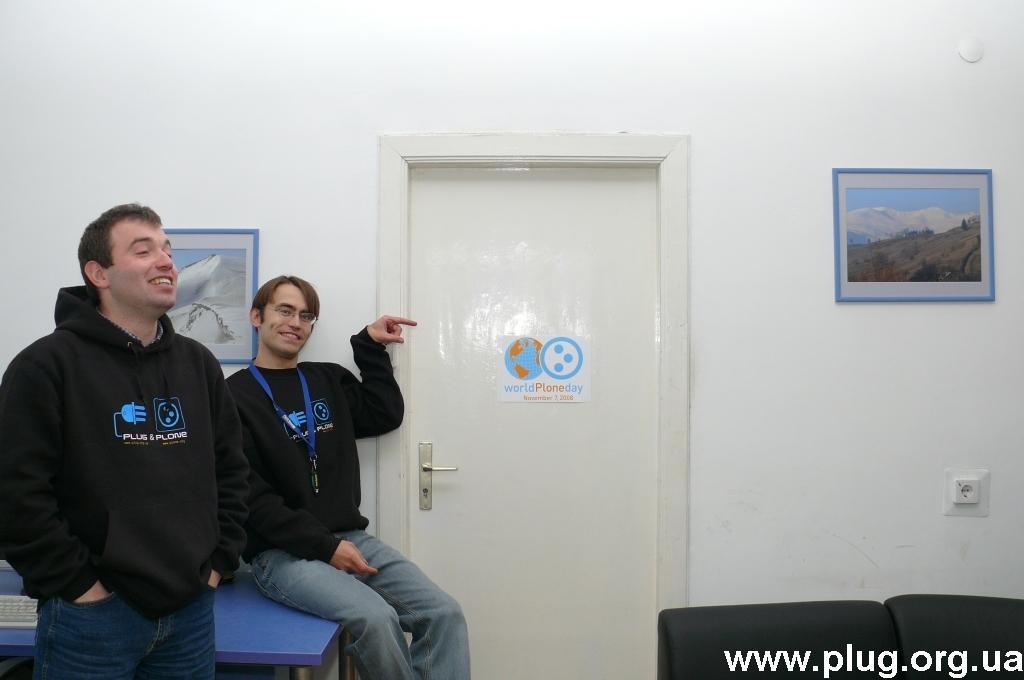How would you summarize this image in a sentence or two? In this image there is a person wearing a black shirt is sitting on the table sitting on the table having a keyboard on it. Left side there is a person wearing black shirt is standing. Right side there are two chairs near the wall having a picture frame attached to it. Beside there is a door. 